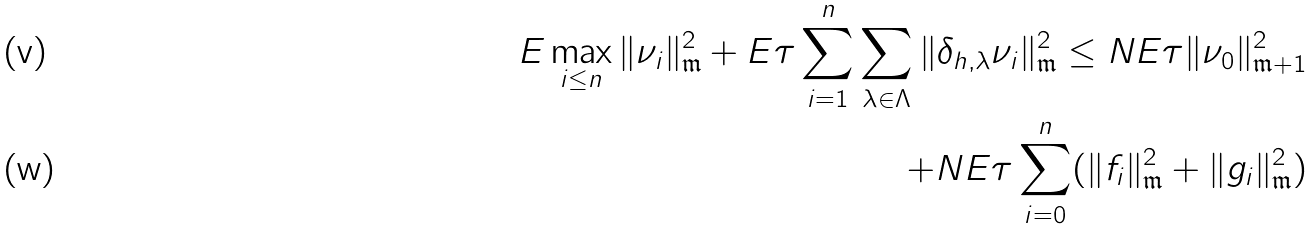<formula> <loc_0><loc_0><loc_500><loc_500>E \max _ { i \leq n } \| \nu _ { i } \| _ { \mathfrak { m } } ^ { 2 } + E \tau \sum _ { i = 1 } ^ { n } \sum _ { \lambda \in \Lambda } \| \delta _ { h , \lambda } \nu _ { i } \| _ { \mathfrak { m } } ^ { 2 } \leq N E \tau \| \nu _ { 0 } \| _ { \mathfrak { m } + 1 } ^ { 2 } \\ + N E \tau \sum _ { i = 0 } ^ { n } ( \| f _ { i } \| _ { \mathfrak { m } } ^ { 2 } + \| g _ { i } \| _ { \mathfrak { m } } ^ { 2 } )</formula> 